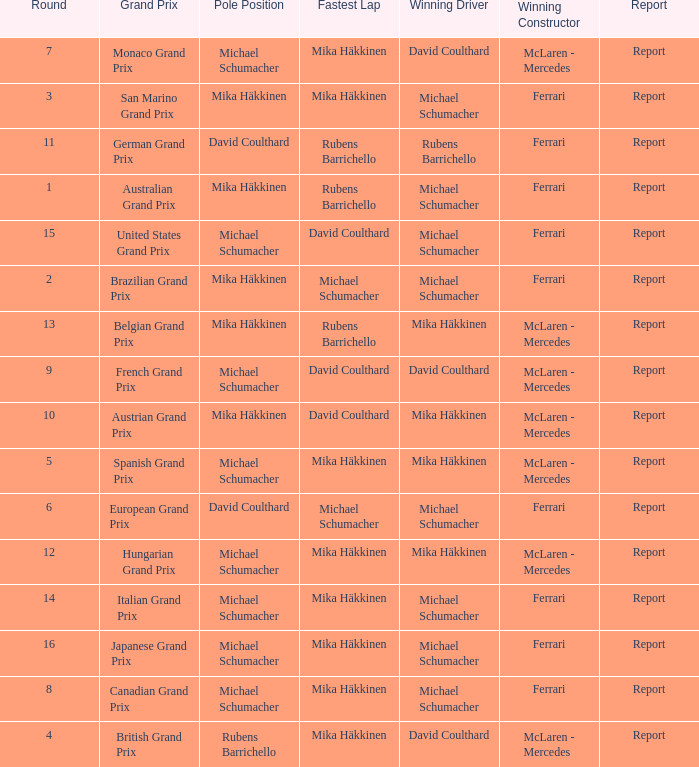What was the report of the Belgian Grand Prix? Report. 